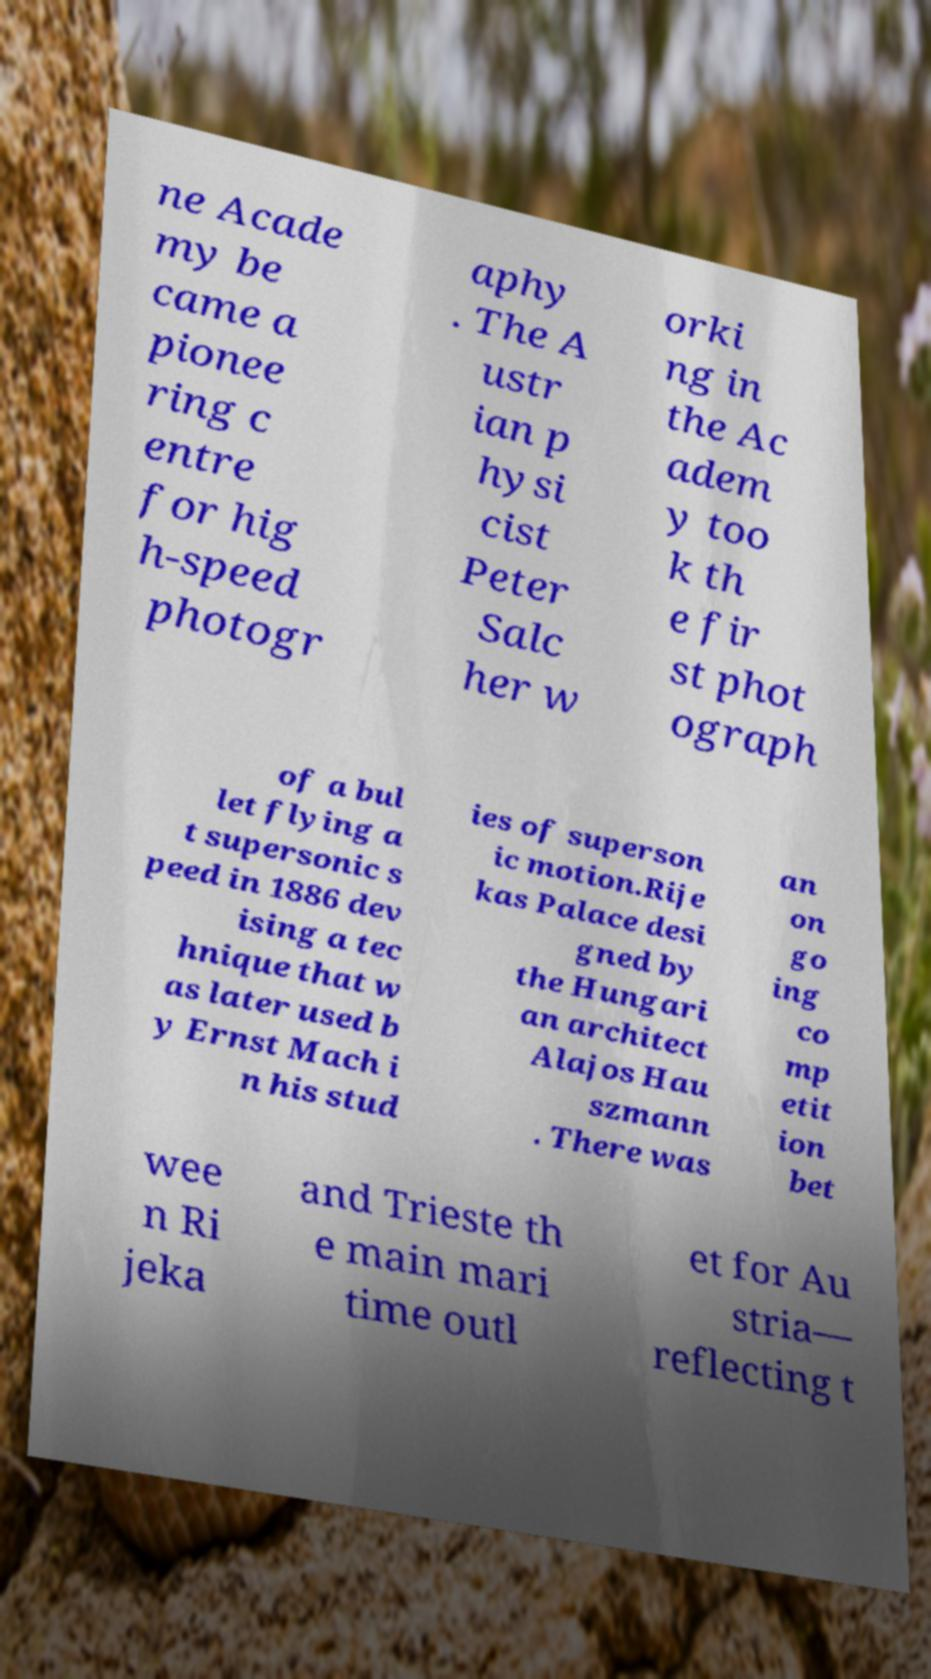There's text embedded in this image that I need extracted. Can you transcribe it verbatim? ne Acade my be came a pionee ring c entre for hig h-speed photogr aphy . The A ustr ian p hysi cist Peter Salc her w orki ng in the Ac adem y too k th e fir st phot ograph of a bul let flying a t supersonic s peed in 1886 dev ising a tec hnique that w as later used b y Ernst Mach i n his stud ies of superson ic motion.Rije kas Palace desi gned by the Hungari an architect Alajos Hau szmann . There was an on go ing co mp etit ion bet wee n Ri jeka and Trieste th e main mari time outl et for Au stria— reflecting t 